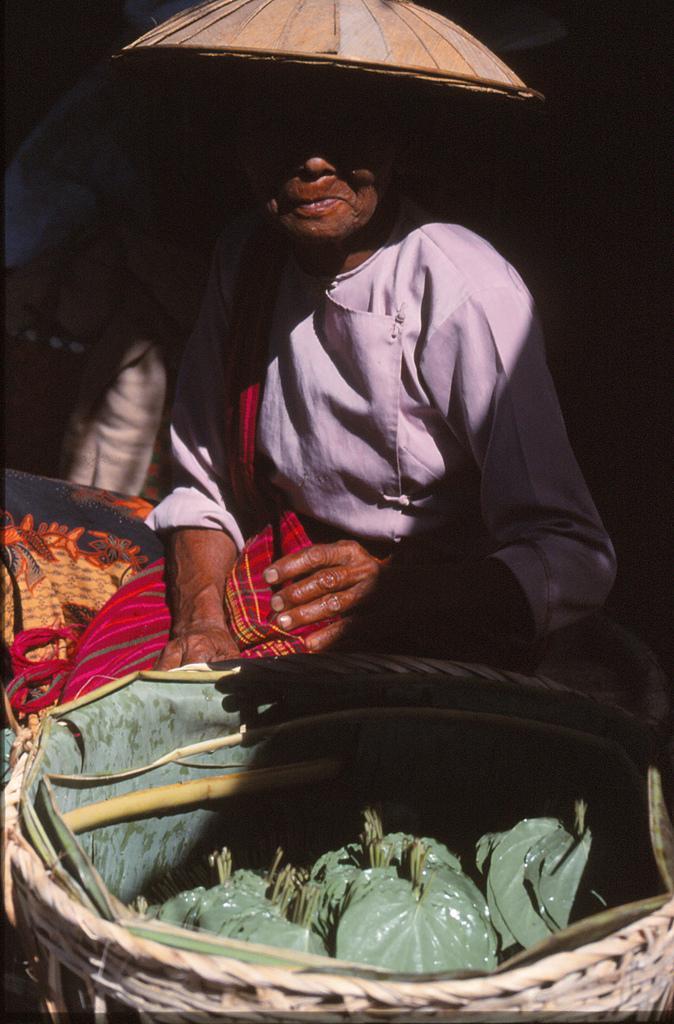How would you summarize this image in a sentence or two? In the image in the center we can see one woman sitting and she is wearing umbrella hat. In front of her,we can see one basket. In basket,we can see leaves. 